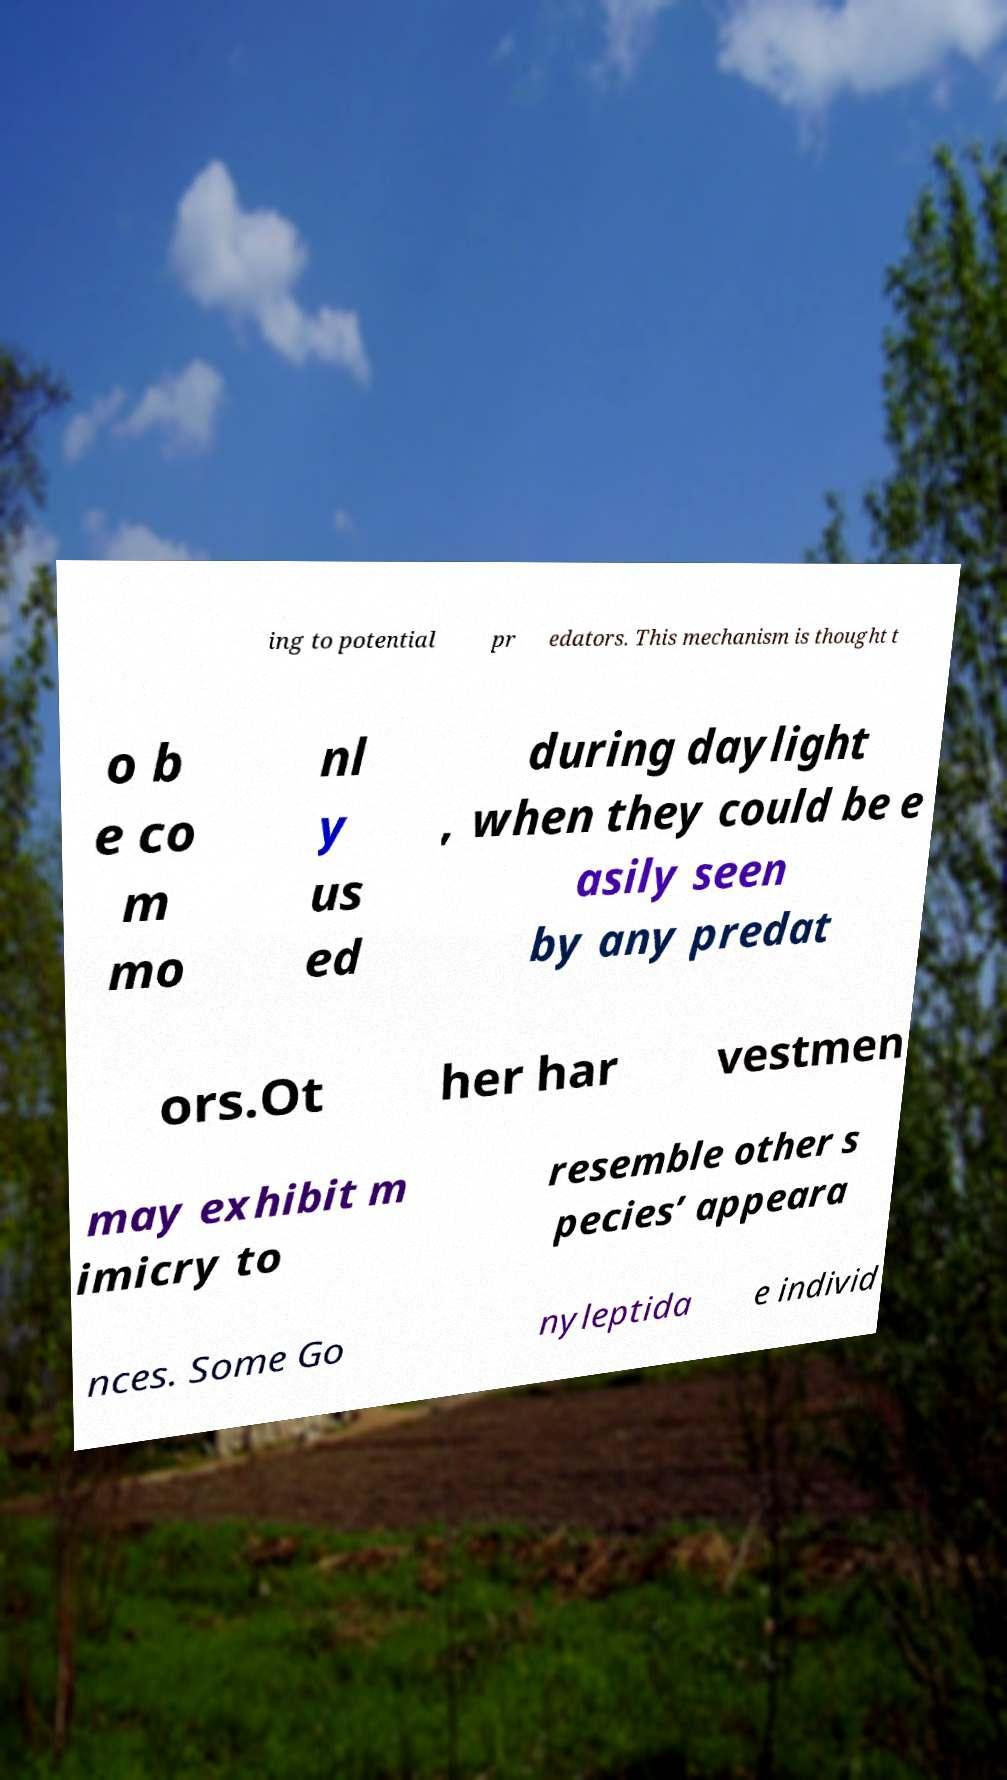Please identify and transcribe the text found in this image. ing to potential pr edators. This mechanism is thought t o b e co m mo nl y us ed during daylight , when they could be e asily seen by any predat ors.Ot her har vestmen may exhibit m imicry to resemble other s pecies’ appeara nces. Some Go nyleptida e individ 